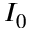Convert formula to latex. <formula><loc_0><loc_0><loc_500><loc_500>I _ { 0 }</formula> 